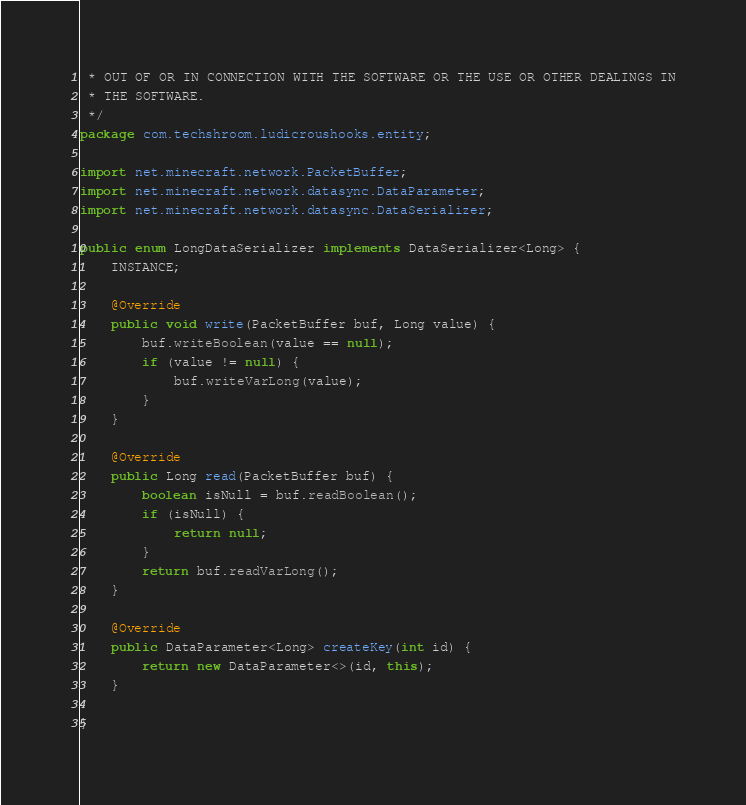Convert code to text. <code><loc_0><loc_0><loc_500><loc_500><_Java_> * OUT OF OR IN CONNECTION WITH THE SOFTWARE OR THE USE OR OTHER DEALINGS IN
 * THE SOFTWARE.
 */
package com.techshroom.ludicroushooks.entity;

import net.minecraft.network.PacketBuffer;
import net.minecraft.network.datasync.DataParameter;
import net.minecraft.network.datasync.DataSerializer;

public enum LongDataSerializer implements DataSerializer<Long> {
    INSTANCE;

    @Override
    public void write(PacketBuffer buf, Long value) {
        buf.writeBoolean(value == null);
        if (value != null) {
            buf.writeVarLong(value);
        }
    }

    @Override
    public Long read(PacketBuffer buf) {
        boolean isNull = buf.readBoolean();
        if (isNull) {
            return null;
        }
        return buf.readVarLong();
    }

    @Override
    public DataParameter<Long> createKey(int id) {
        return new DataParameter<>(id, this);
    }

}
</code> 